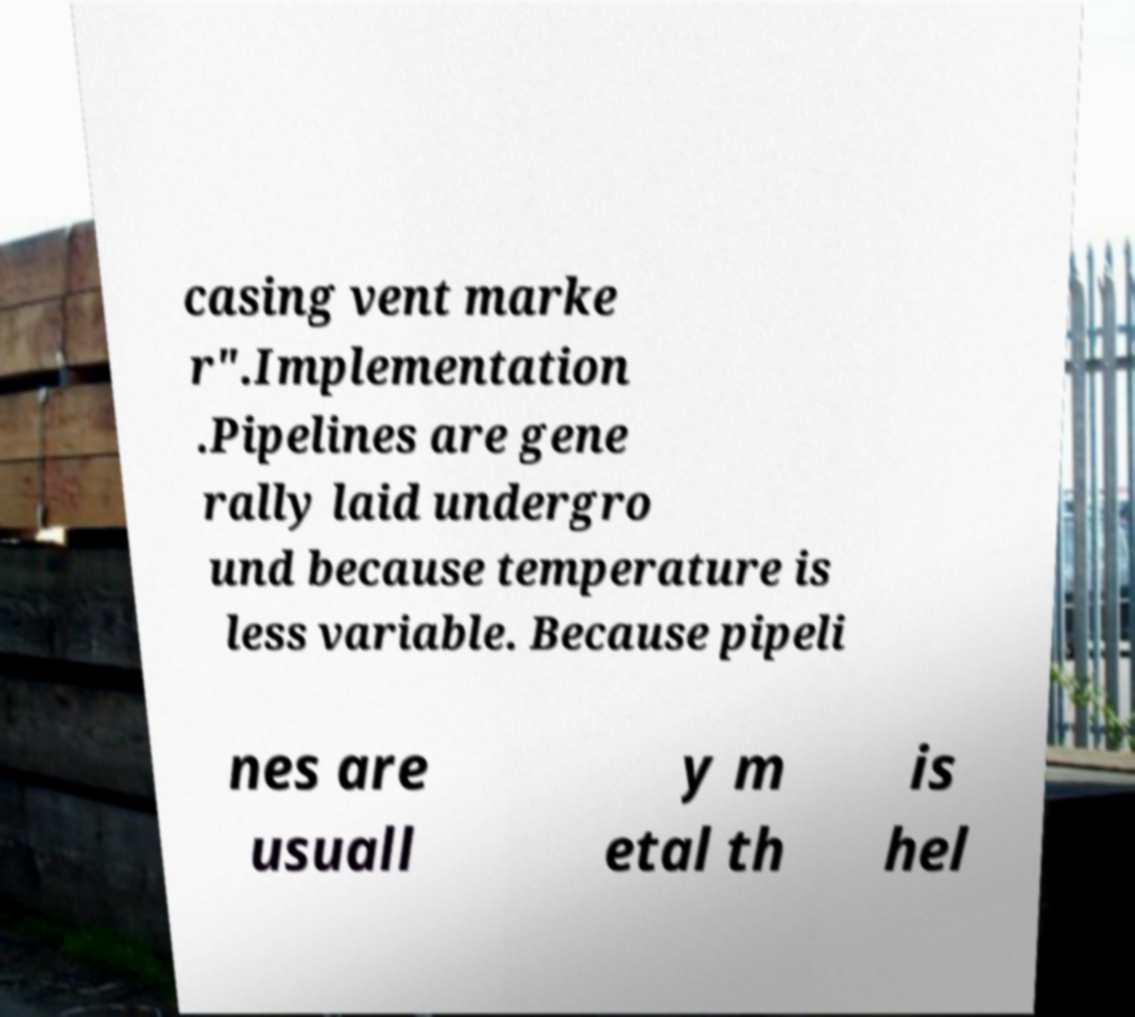Please identify and transcribe the text found in this image. casing vent marke r".Implementation .Pipelines are gene rally laid undergro und because temperature is less variable. Because pipeli nes are usuall y m etal th is hel 